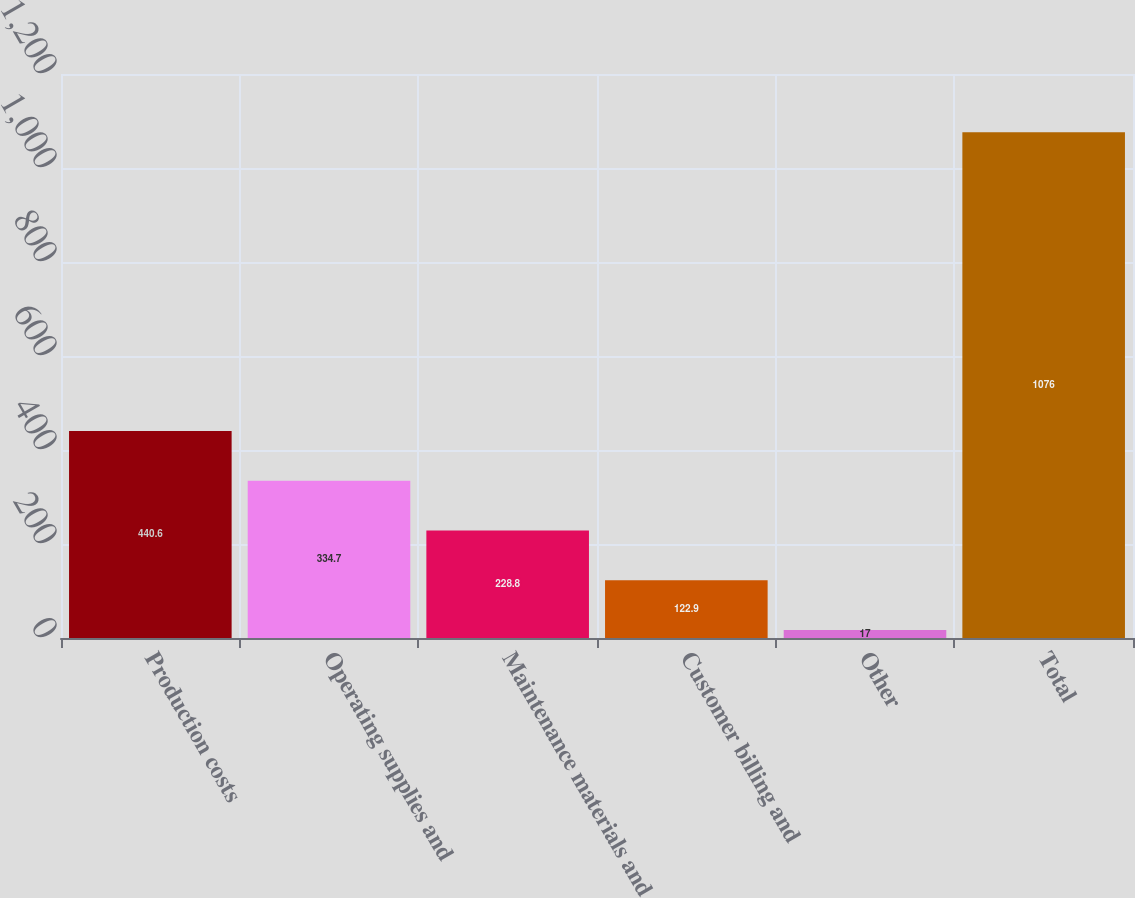Convert chart. <chart><loc_0><loc_0><loc_500><loc_500><bar_chart><fcel>Production costs<fcel>Operating supplies and<fcel>Maintenance materials and<fcel>Customer billing and<fcel>Other<fcel>Total<nl><fcel>440.6<fcel>334.7<fcel>228.8<fcel>122.9<fcel>17<fcel>1076<nl></chart> 